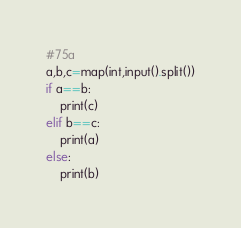Convert code to text. <code><loc_0><loc_0><loc_500><loc_500><_Python_>#75a
a,b,c=map(int,input().split())
if a==b:
    print(c)
elif b==c:
    print(a)
else:
    print(b)</code> 